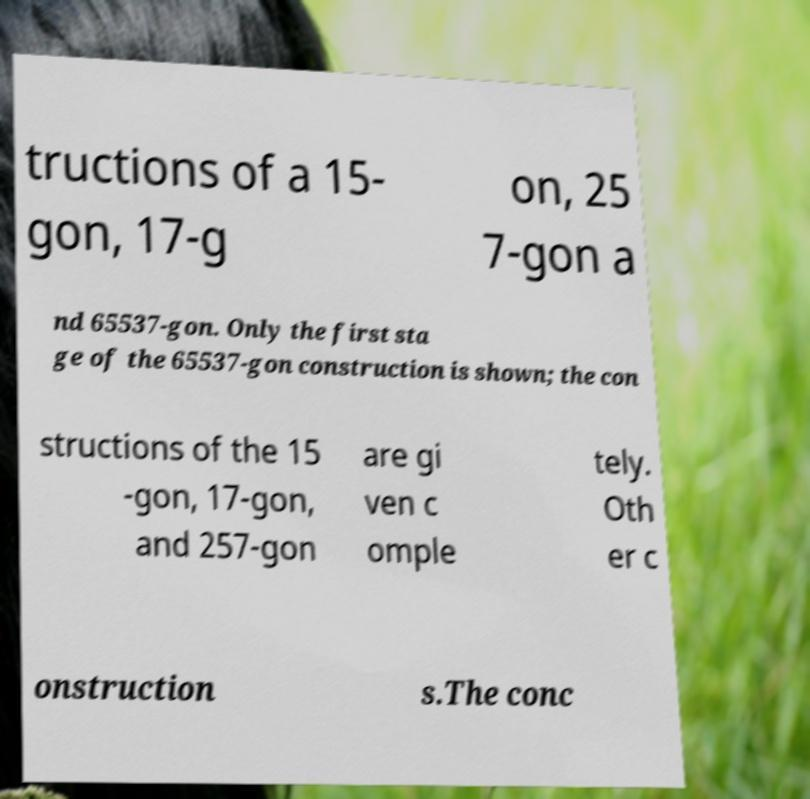Can you read and provide the text displayed in the image?This photo seems to have some interesting text. Can you extract and type it out for me? tructions of a 15- gon, 17-g on, 25 7-gon a nd 65537-gon. Only the first sta ge of the 65537-gon construction is shown; the con structions of the 15 -gon, 17-gon, and 257-gon are gi ven c omple tely. Oth er c onstruction s.The conc 